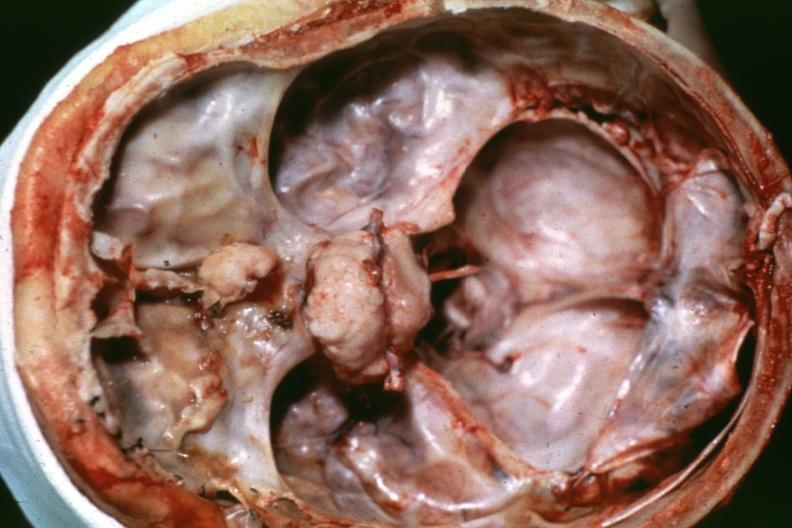s bone, calvarium present?
Answer the question using a single word or phrase. Yes 